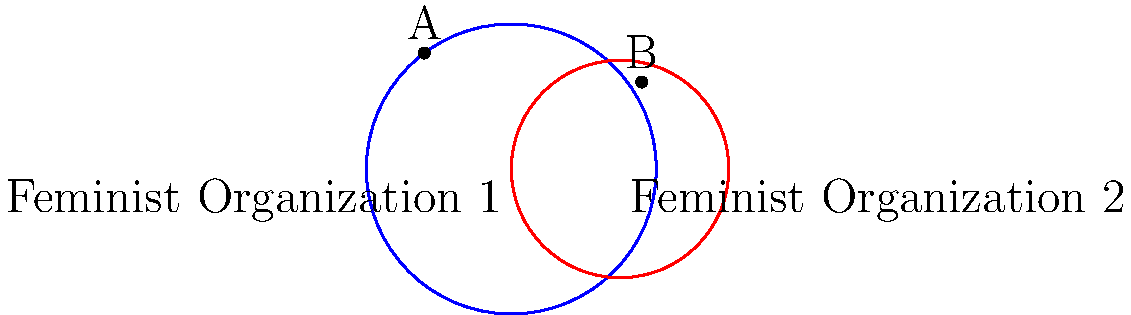Two feminist organizations are represented by circles in the diagram, with their centers at (0,0) and (3,0), and radii of 4 and 3 units respectively. These circles represent the organizations' spheres of influence. Calculate the y-coordinate of the upper intersection point (point A) of these two circles. Round your answer to two decimal places. To find the y-coordinate of the upper intersection point, we can follow these steps:

1) The equation of the first circle (centered at (0,0) with radius 4) is:
   $$x^2 + y^2 = 16$$

2) The equation of the second circle (centered at (3,0) with radius 3) is:
   $$(x-3)^2 + y^2 = 9$$

3) To find the intersection points, we need to solve these equations simultaneously. Subtracting the second equation from the first:

   $$x^2 + y^2 - ((x-3)^2 + y^2) = 16 - 9$$
   $$x^2 - (x^2 - 6x + 9) = 7$$
   $$6x - 9 = 7$$
   $$6x = 16$$
   $$x = \frac{8}{3}$$

4) Substitute this x-value back into the equation of the first circle:

   $$(\frac{8}{3})^2 + y^2 = 16$$
   $$\frac{64}{9} + y^2 = 16$$
   $$y^2 = 16 - \frac{64}{9} = \frac{80}{9}$$
   $$y = \pm \sqrt{\frac{80}{9}} \approx \pm 2.98$$

5) The positive value represents the y-coordinate of the upper intersection point (A).
Answer: 2.98 